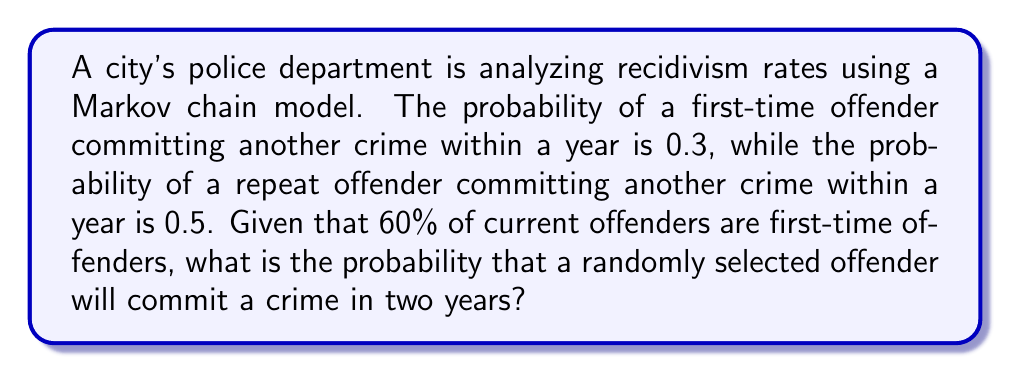Can you solve this math problem? Let's approach this problem step-by-step using Markov chains:

1) First, let's define our states:
   State 0: First-time offender
   State 1: Repeat offender

2) We can represent the transition probabilities in a matrix:

   $$P = \begin{bmatrix}
   0.7 & 0.3 \\
   0.5 & 0.5
   \end{bmatrix}$$

   Where $P_{ij}$ is the probability of moving from state $i$ to state $j$.

3) The initial state vector is:

   $$\pi_0 = \begin{bmatrix} 0.6 & 0.4 \end{bmatrix}$$

   This represents that 60% are first-time offenders and 40% are repeat offenders.

4) To find the probability distribution after two years, we need to multiply the initial state vector by the transition matrix twice:

   $$\pi_2 = \pi_0 P^2$$

5) Let's calculate $P^2$:

   $$P^2 = \begin{bmatrix}
   0.7 & 0.3 \\
   0.5 & 0.5
   \end{bmatrix} \times \begin{bmatrix}
   0.7 & 0.3 \\
   0.5 & 0.5
   \end{bmatrix} = \begin{bmatrix}
   0.64 & 0.36 \\
   0.6 & 0.4
   \end{bmatrix}$$

6) Now, let's multiply $\pi_0$ by $P^2$:

   $$\pi_2 = \begin{bmatrix} 0.6 & 0.4 \end{bmatrix} \times \begin{bmatrix}
   0.64 & 0.36 \\
   0.6 & 0.4
   \end{bmatrix} = \begin{bmatrix} 0.624 & 0.376 \end{bmatrix}$$

7) The probability of committing a crime in two years is the sum of the probabilities of being in either state and then committing a crime:

   $$(0.624 \times 0.3) + (0.376 \times 0.5) = 0.1872 + 0.188 = 0.3752$$

Therefore, the probability that a randomly selected offender will commit a crime in two years is approximately 0.3752 or 37.52%.
Answer: 0.3752 or 37.52% 